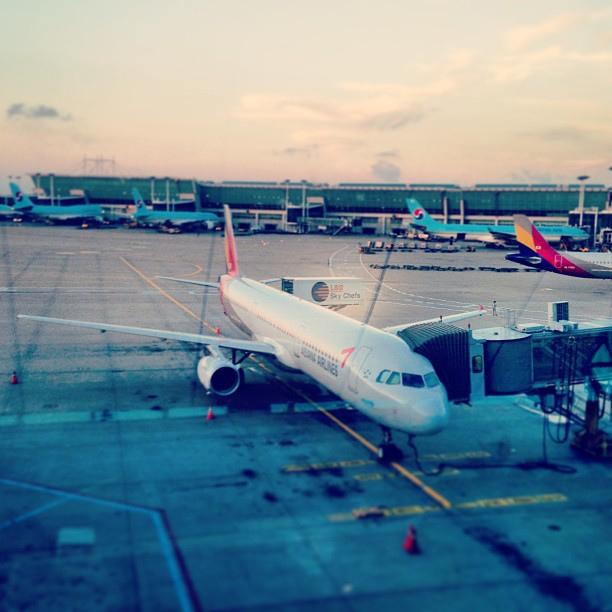What airline owns the plane?
Be succinct. United. Where is the plane?
Write a very short answer. Airport. How many planes are pictured?
Be succinct. 5. Are they loading the plane?
Short answer required. Yes. Is this a big airport?
Concise answer only. Yes. 